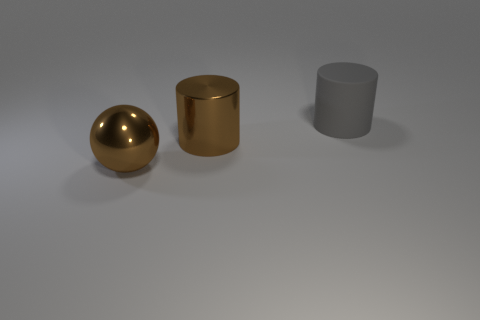Add 2 big gray matte things. How many objects exist? 5 Subtract all cylinders. How many objects are left? 1 Subtract all big purple cylinders. Subtract all brown metallic cylinders. How many objects are left? 2 Add 3 big metallic objects. How many big metallic objects are left? 5 Add 1 large rubber cylinders. How many large rubber cylinders exist? 2 Subtract 0 green balls. How many objects are left? 3 